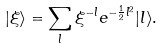<formula> <loc_0><loc_0><loc_500><loc_500>| \xi \rangle = \sum _ { l } \xi ^ { - l } e ^ { - \frac { 1 } { 2 } l ^ { 2 } } | l \rangle .</formula> 